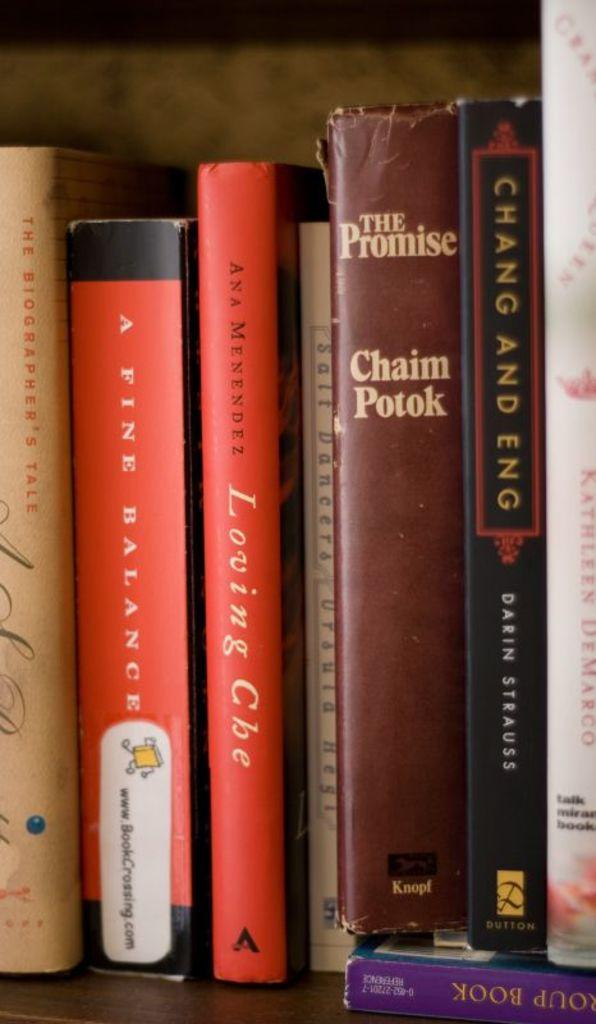Provide a one-sentence caption for the provided image. several books on a shelf including a fine balance, the promise, and chang and eng. 